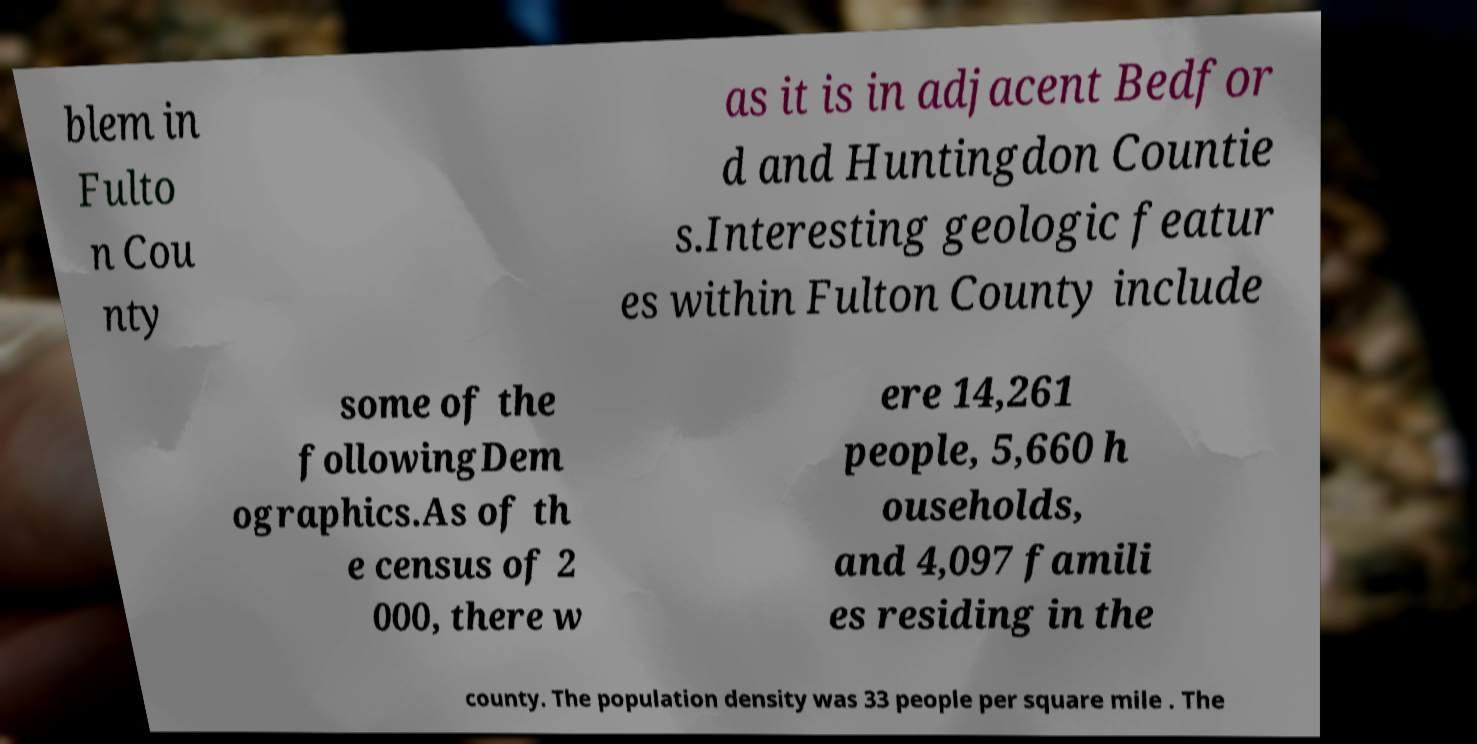I need the written content from this picture converted into text. Can you do that? blem in Fulto n Cou nty as it is in adjacent Bedfor d and Huntingdon Countie s.Interesting geologic featur es within Fulton County include some of the followingDem ographics.As of th e census of 2 000, there w ere 14,261 people, 5,660 h ouseholds, and 4,097 famili es residing in the county. The population density was 33 people per square mile . The 